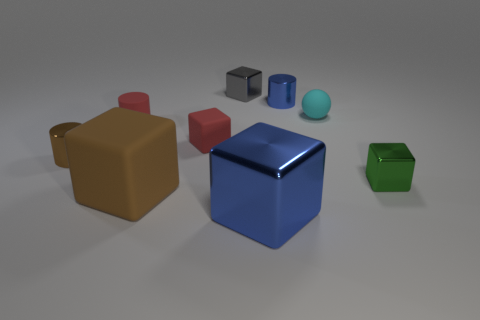Subtract all red cubes. How many cubes are left? 4 Subtract all small green shiny cubes. How many cubes are left? 4 Subtract all cyan blocks. Subtract all green spheres. How many blocks are left? 5 Add 1 cubes. How many objects exist? 10 Subtract all balls. How many objects are left? 8 Add 8 small red matte things. How many small red matte things exist? 10 Subtract 0 red balls. How many objects are left? 9 Subtract all big gray metal cubes. Subtract all small cubes. How many objects are left? 6 Add 1 rubber things. How many rubber things are left? 5 